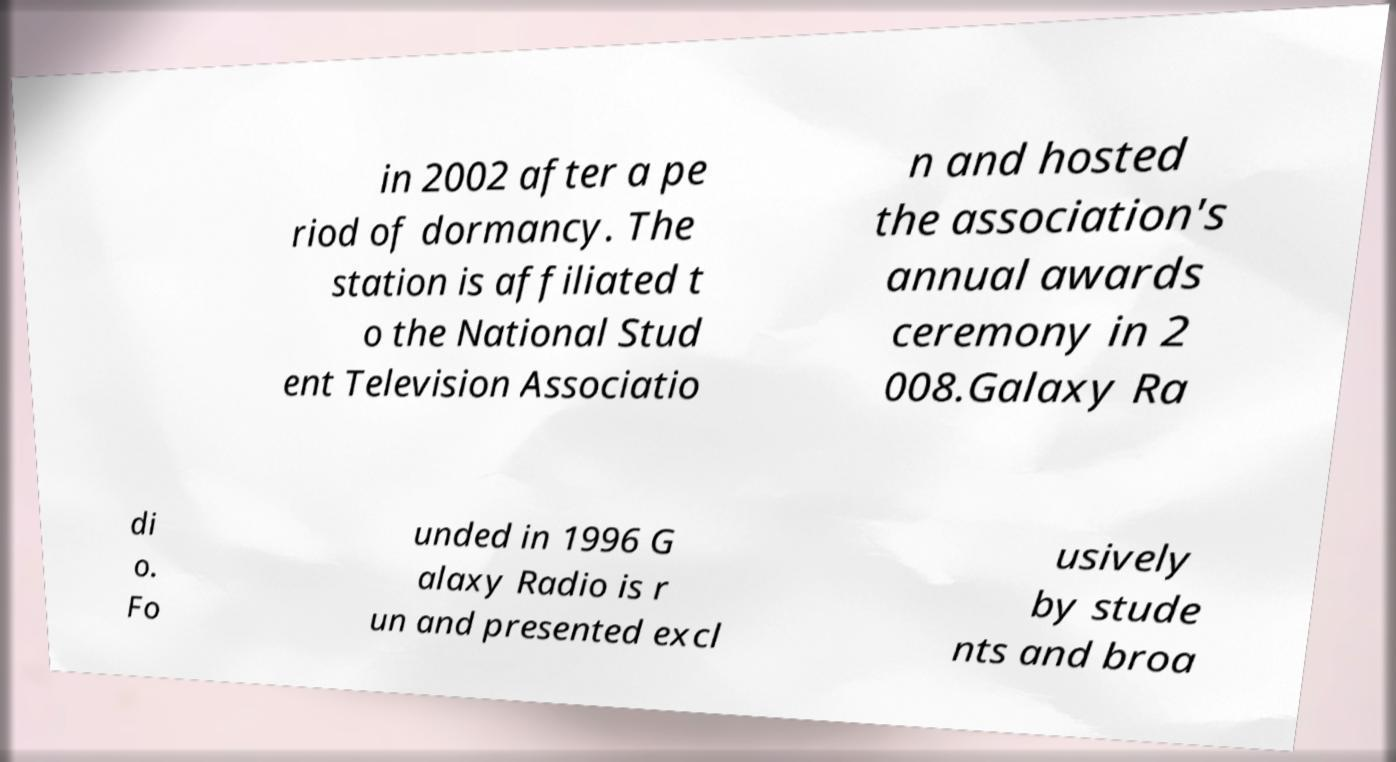Could you assist in decoding the text presented in this image and type it out clearly? in 2002 after a pe riod of dormancy. The station is affiliated t o the National Stud ent Television Associatio n and hosted the association's annual awards ceremony in 2 008.Galaxy Ra di o. Fo unded in 1996 G alaxy Radio is r un and presented excl usively by stude nts and broa 